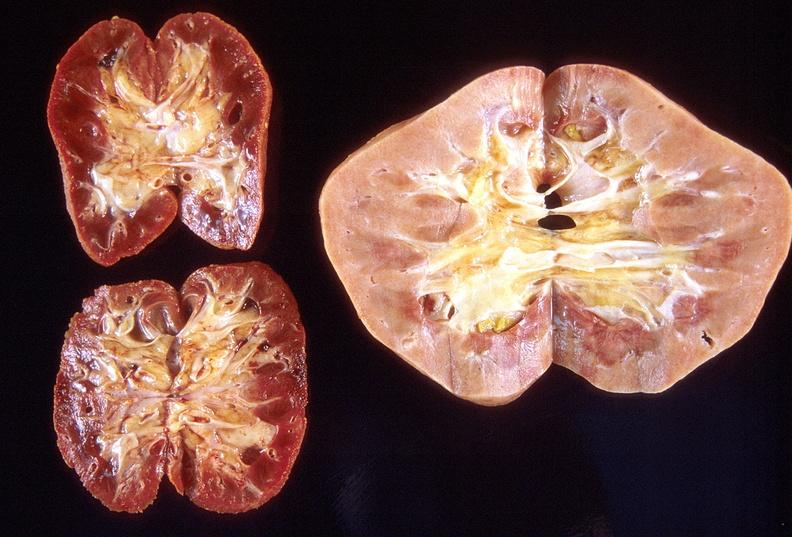what does this image show?
Answer the question using a single word or phrase. Left - native end stage kidneys right - renal allograft abdominal 